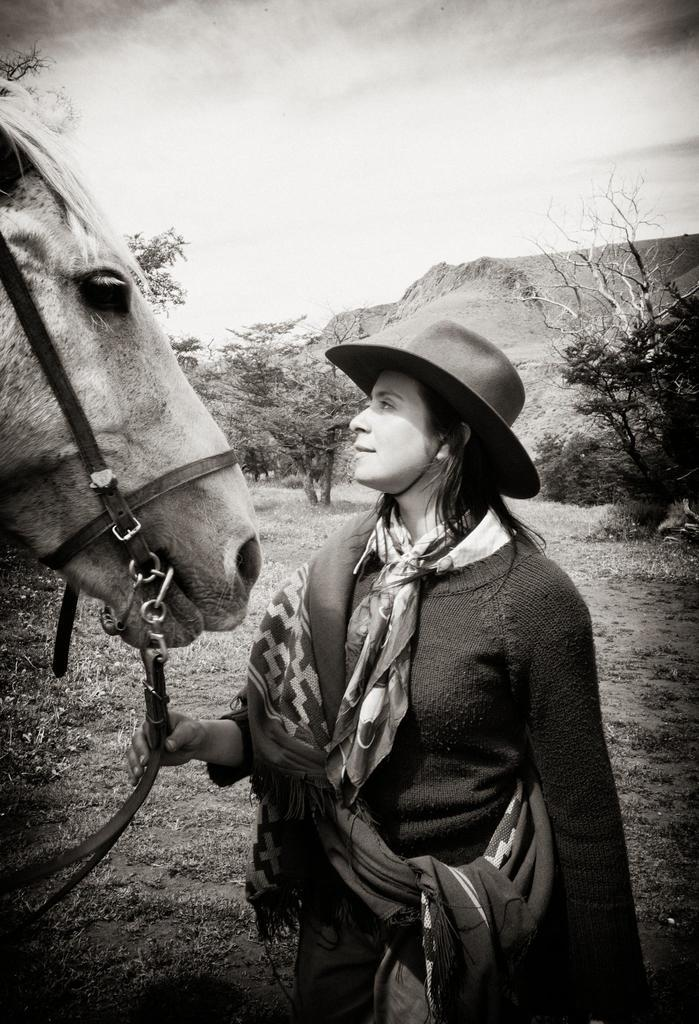What is the color scheme of the image? The image is black and white. Who is present in the image? There is a woman in the image. What is the woman doing in the image? The woman is standing beside a horse. What type of natural environment is visible in the image? There are trees and the sky visible in the image. How many chins does the woman have in the image? The number of chins the woman has cannot be determined from the image, as it is black and white and does not provide enough detail. --- Facts: 1. There is a car in the image. 2. The car is red. 3. The car has four wheels. 4. There are people in the car. 5. The car is parked on the street. Absurd Topics: parrot, ocean, dance Conversation: What is the main subject of the image? The main subject of the image is a car. What color is the car? The car is red. How many wheels does the car have? The car has four wheels. Are there any passengers in the car? Yes, there are people in the car. Where is the car located in the image? The car is parked on the street. Reasoning: Let's think step by step in order to produce the conversation. We start by identifying the main subject of the image, which is the car. Then, we describe the car's color and number of wheels. Next, we mention the presence of passengers in the car. Finally, we describe the car's location, which is parked on the street. Absurd Question/Answer: Can you see a parrot flying over the ocean in the image? No, there is no parrot or ocean present in the image; it features a red car parked on the street. 